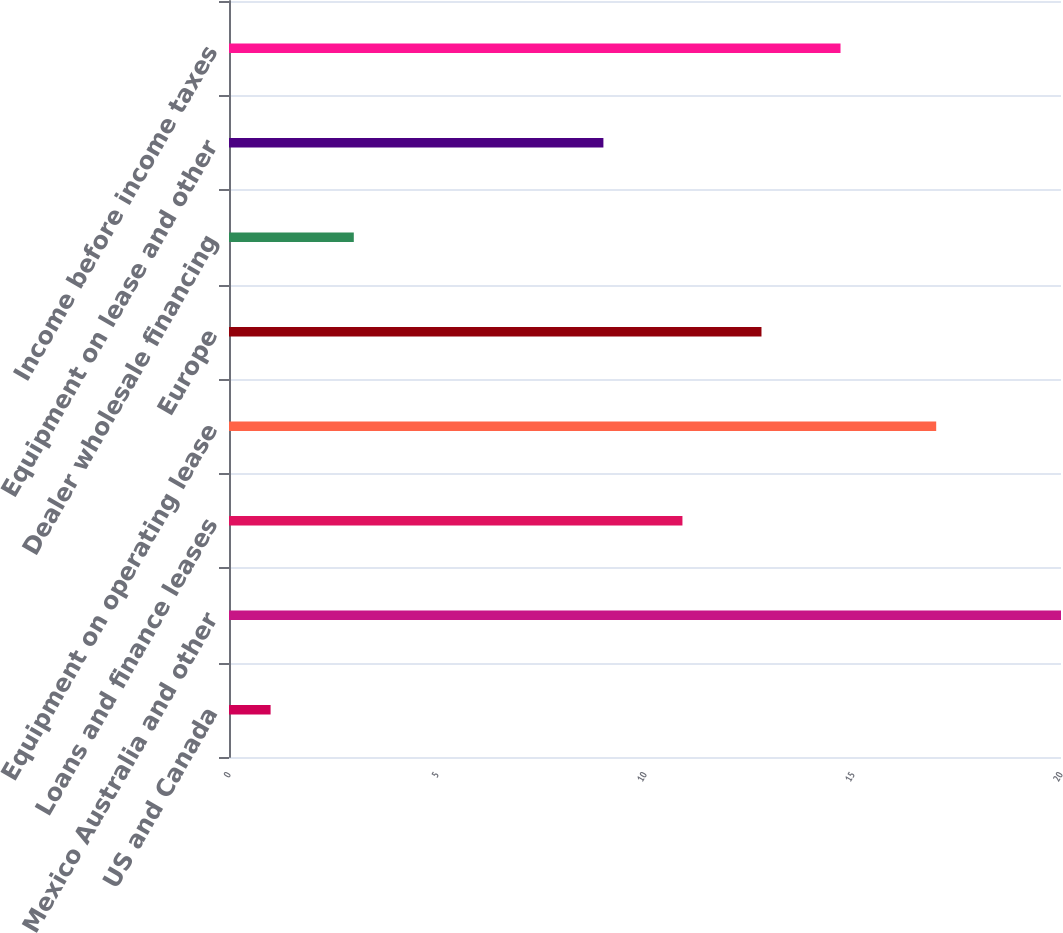Convert chart. <chart><loc_0><loc_0><loc_500><loc_500><bar_chart><fcel>US and Canada<fcel>Mexico Australia and other<fcel>Loans and finance leases<fcel>Equipment on operating lease<fcel>Europe<fcel>Dealer wholesale financing<fcel>Equipment on lease and other<fcel>Income before income taxes<nl><fcel>1<fcel>20<fcel>10.9<fcel>17<fcel>12.8<fcel>3<fcel>9<fcel>14.7<nl></chart> 